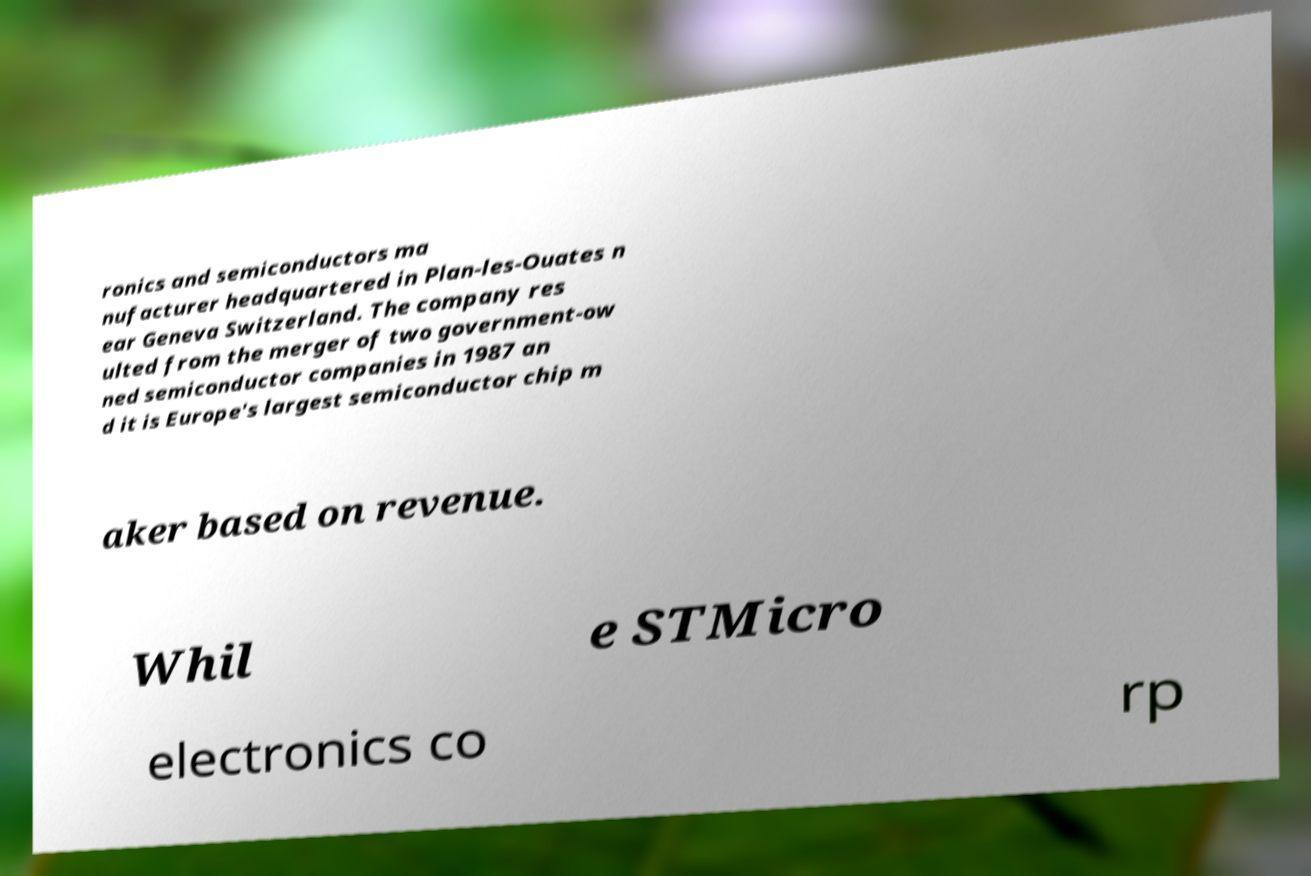Could you extract and type out the text from this image? ronics and semiconductors ma nufacturer headquartered in Plan-les-Ouates n ear Geneva Switzerland. The company res ulted from the merger of two government-ow ned semiconductor companies in 1987 an d it is Europe's largest semiconductor chip m aker based on revenue. Whil e STMicro electronics co rp 